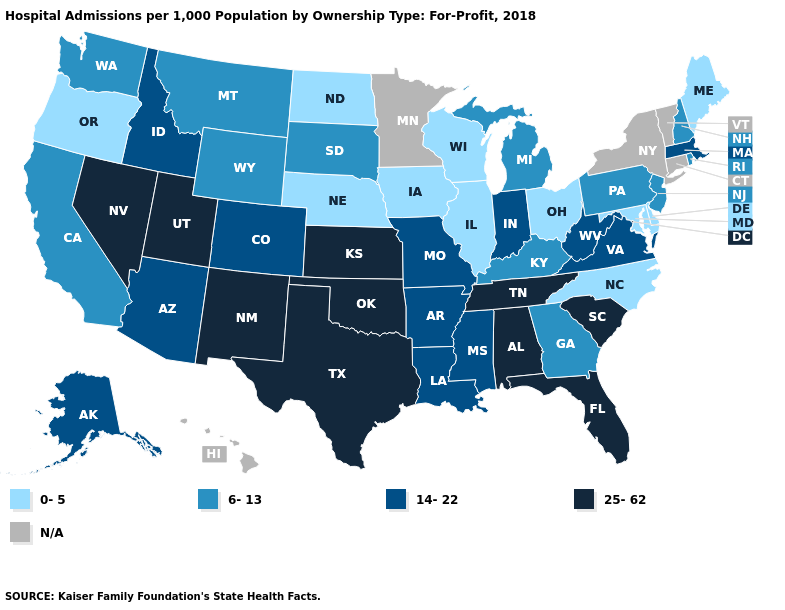What is the lowest value in states that border Pennsylvania?
Write a very short answer. 0-5. What is the value of Illinois?
Answer briefly. 0-5. What is the highest value in states that border Michigan?
Short answer required. 14-22. Which states have the lowest value in the USA?
Short answer required. Delaware, Illinois, Iowa, Maine, Maryland, Nebraska, North Carolina, North Dakota, Ohio, Oregon, Wisconsin. Does Nebraska have the lowest value in the USA?
Be succinct. Yes. Does Delaware have the lowest value in the South?
Quick response, please. Yes. What is the highest value in states that border Vermont?
Concise answer only. 14-22. Among the states that border New Hampshire , which have the highest value?
Short answer required. Massachusetts. What is the value of Connecticut?
Write a very short answer. N/A. Name the states that have a value in the range 0-5?
Quick response, please. Delaware, Illinois, Iowa, Maine, Maryland, Nebraska, North Carolina, North Dakota, Ohio, Oregon, Wisconsin. What is the value of California?
Be succinct. 6-13. What is the highest value in the USA?
Quick response, please. 25-62. Does Alaska have the highest value in the West?
Keep it brief. No. What is the highest value in states that border Alabama?
Quick response, please. 25-62. 